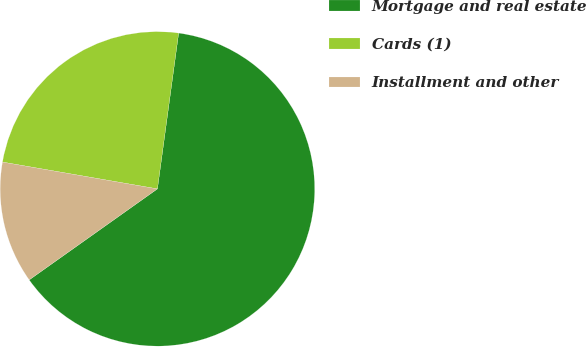<chart> <loc_0><loc_0><loc_500><loc_500><pie_chart><fcel>Mortgage and real estate<fcel>Cards (1)<fcel>Installment and other<nl><fcel>63.02%<fcel>24.43%<fcel>12.55%<nl></chart> 